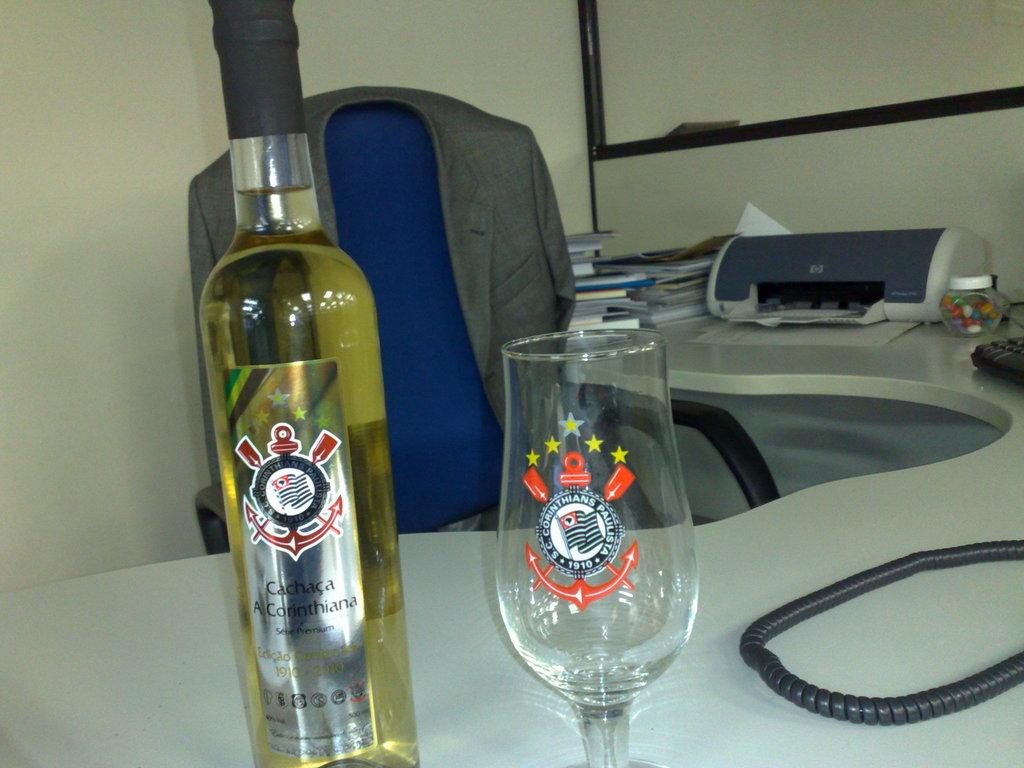<image>
Give a short and clear explanation of the subsequent image. A bottle of Cachaca A Corinthiana sits on a desk next to an empty glass. 